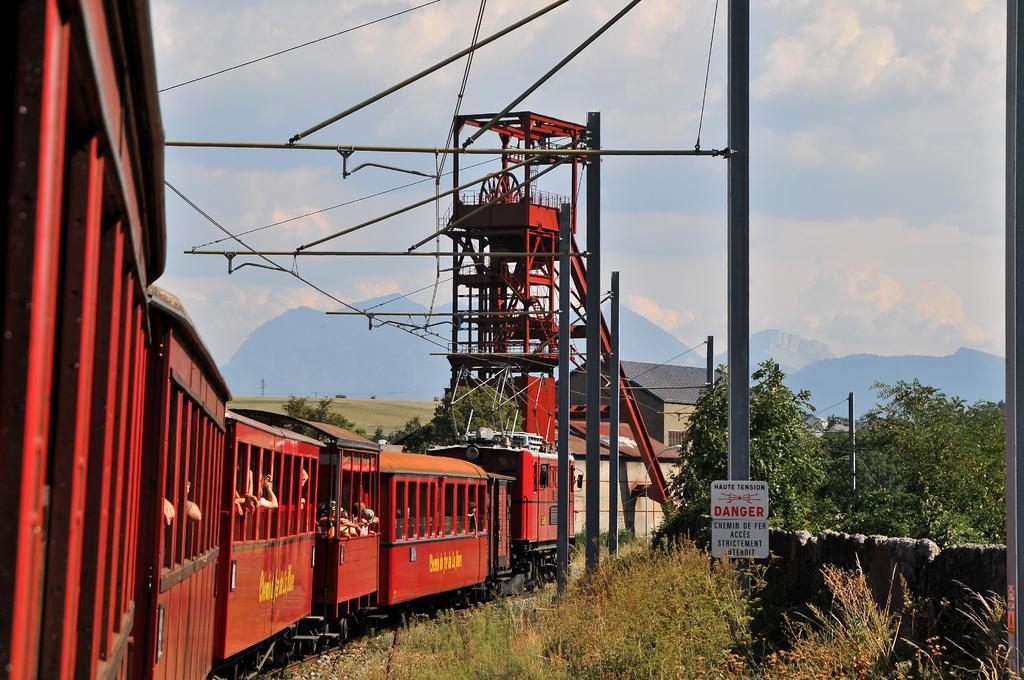How would you summarize this image in a sentence or two? In the center of the image we can see trains, some persons, tower, rods, wires, poles, house, trees, board, wall are present. At the top of the image clouds are present in the sky. In the middle of the image hills are there. At the bottom of the image some plants, ground are present. 